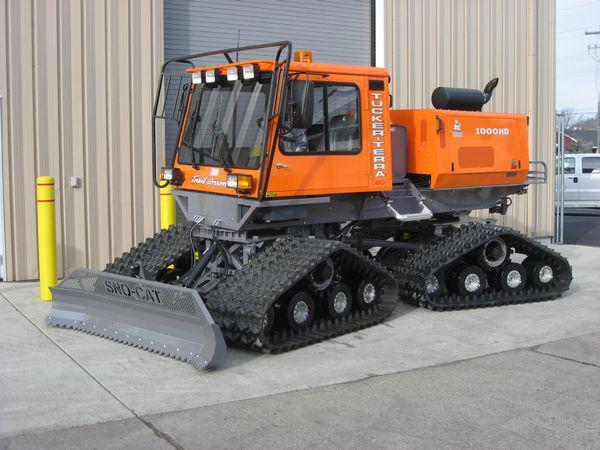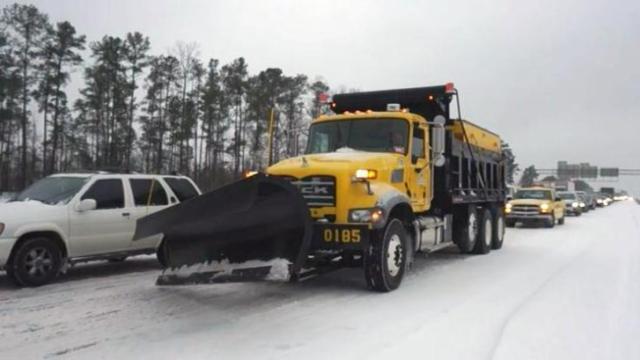The first image is the image on the left, the second image is the image on the right. Examine the images to the left and right. Is the description "At least one image shows a vehicle with tank-like tracks instead of wheels." accurate? Answer yes or no. Yes. 